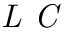Convert formula to latex. <formula><loc_0><loc_0><loc_500><loc_500>L C</formula> 